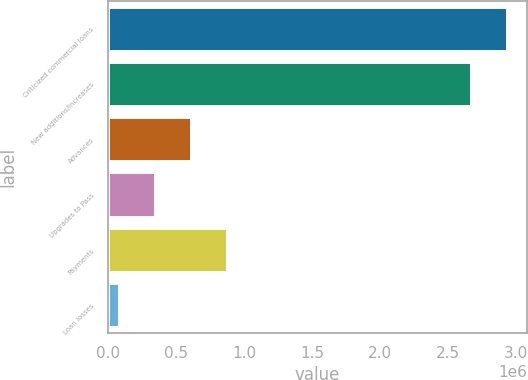Convert chart to OTSL. <chart><loc_0><loc_0><loc_500><loc_500><bar_chart><fcel>Criticized commercial loans<fcel>New additions/increases<fcel>Advances<fcel>Upgrades to Pass<fcel>Payments<fcel>Loan losses<nl><fcel>2.93655e+06<fcel>2.67062e+06<fcel>608705<fcel>342773<fcel>874638<fcel>76840<nl></chart> 